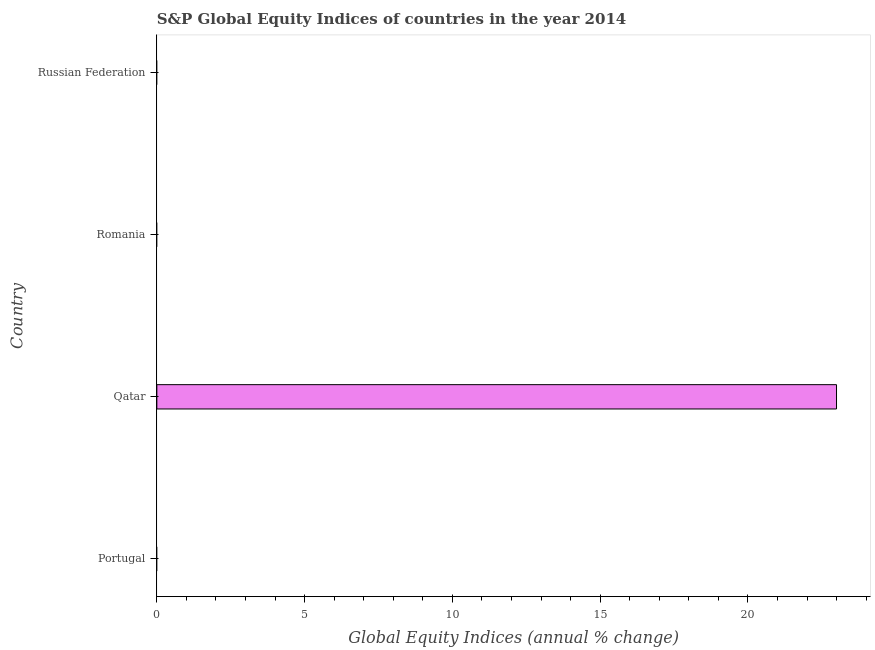What is the title of the graph?
Ensure brevity in your answer.  S&P Global Equity Indices of countries in the year 2014. What is the label or title of the X-axis?
Offer a very short reply. Global Equity Indices (annual % change). What is the label or title of the Y-axis?
Give a very brief answer. Country. Across all countries, what is the maximum s&p global equity indices?
Your answer should be very brief. 23. Across all countries, what is the minimum s&p global equity indices?
Give a very brief answer. 0. In which country was the s&p global equity indices maximum?
Provide a short and direct response. Qatar. What is the sum of the s&p global equity indices?
Your response must be concise. 23. What is the average s&p global equity indices per country?
Offer a terse response. 5.75. What is the median s&p global equity indices?
Your answer should be compact. 0. In how many countries, is the s&p global equity indices greater than the average s&p global equity indices taken over all countries?
Offer a very short reply. 1. How many bars are there?
Keep it short and to the point. 1. How many countries are there in the graph?
Your answer should be very brief. 4. What is the Global Equity Indices (annual % change) of Qatar?
Give a very brief answer. 23. 